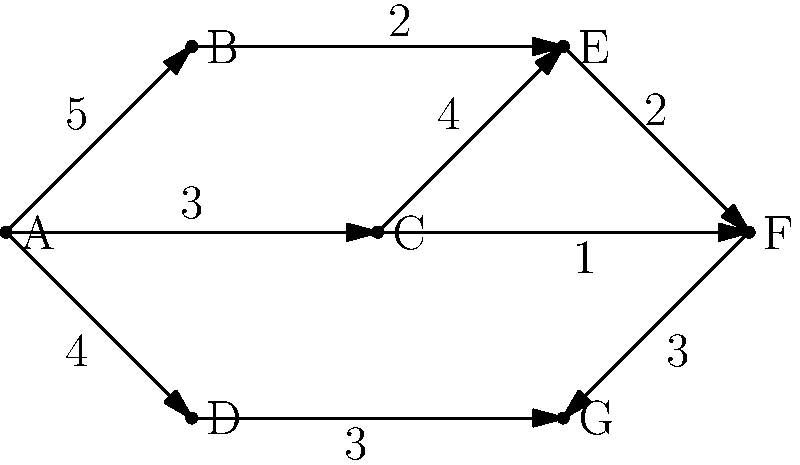Given the weighted directed graph representing a public transportation network, where vertices represent stations and edge weights represent travel times in minutes, find the shortest path from station A to station G using Dijkstra's algorithm. What is the total travel time of this optimal route? To solve this problem using Dijkstra's algorithm, we'll follow these steps:

1) Initialize:
   - Set distance to A as 0, and all other vertices as infinity.
   - Set all vertices as unvisited.
   - Set A as the current vertex.

2) For the current vertex, consider all unvisited neighbors and calculate their tentative distances.
   - If the calculated distance is less than the previously recorded distance, update it.

3) Mark the current vertex as visited.

4) If G has been visited or all unvisited vertices have infinite distances, finish.
   Otherwise, set the unvisited vertex with the smallest tentative distance as the new current vertex and go to step 2.

Let's apply the algorithm:

- Start at A: distance[A]=0, distance[B]=5, distance[C]=3, distance[D]=4
- Visit B: distance[E]=5+2=7
- Visit C: distance[E]=min(7,3+4)=7, distance[F]=3+1=4
- Visit D: distance[G]=4+3=7
- Visit F: distance[G]=min(7,4+3)=7
- Visit E: No change
- Visit G: Algorithm ends

The shortest path is A → C → F → G with a total distance of 7 minutes.
Answer: 7 minutes 